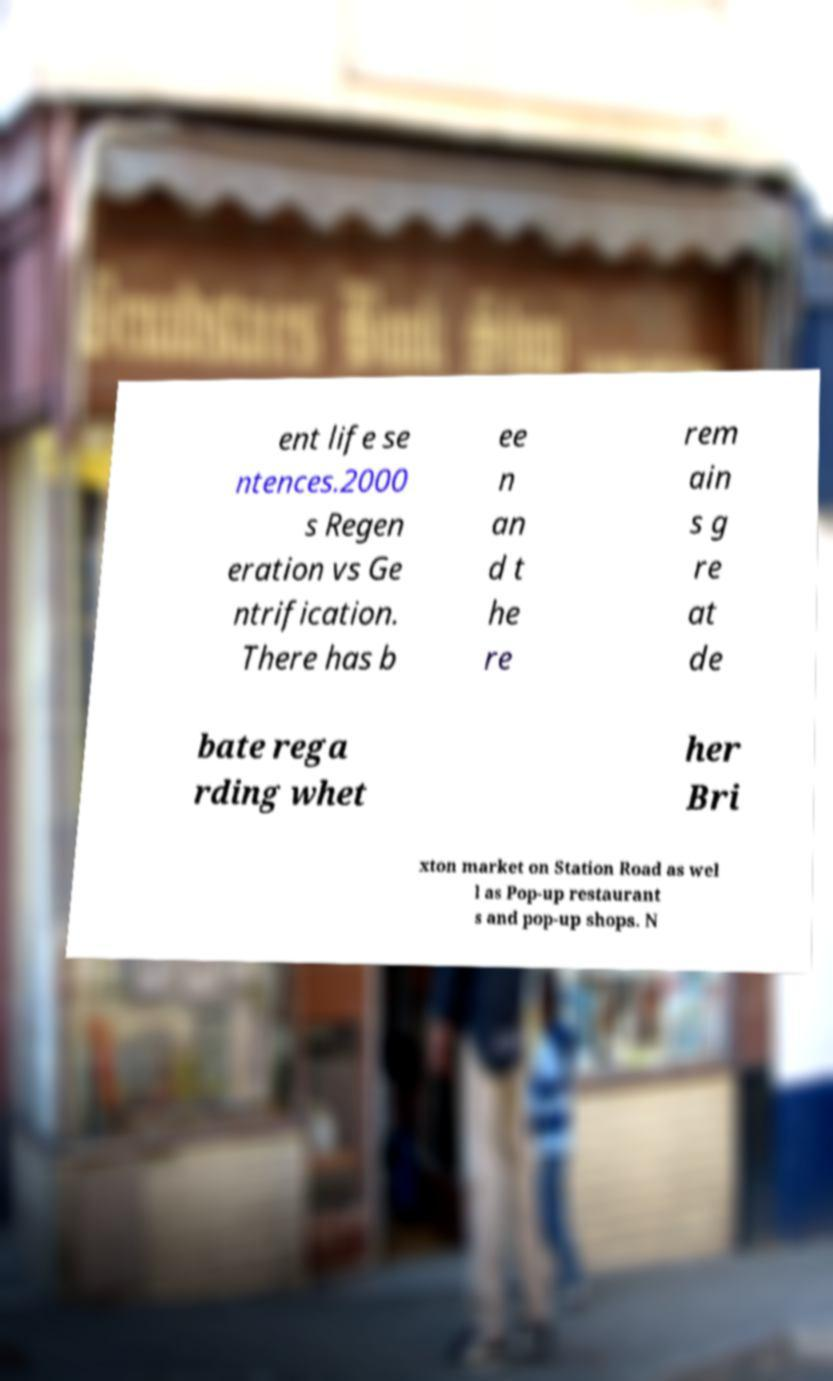Can you read and provide the text displayed in the image?This photo seems to have some interesting text. Can you extract and type it out for me? ent life se ntences.2000 s Regen eration vs Ge ntrification. There has b ee n an d t he re rem ain s g re at de bate rega rding whet her Bri xton market on Station Road as wel l as Pop-up restaurant s and pop-up shops. N 